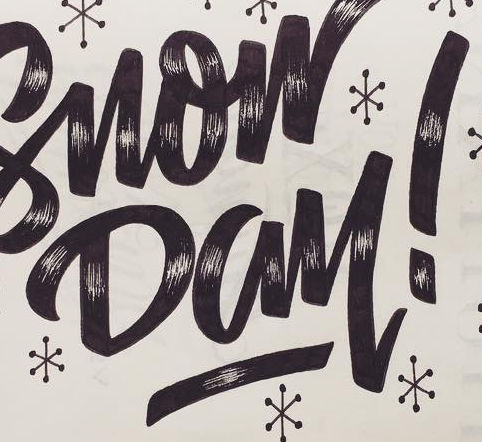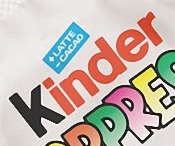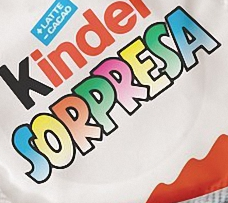Read the text from these images in sequence, separated by a semicolon. Day!; Kinder; SORPRESA 